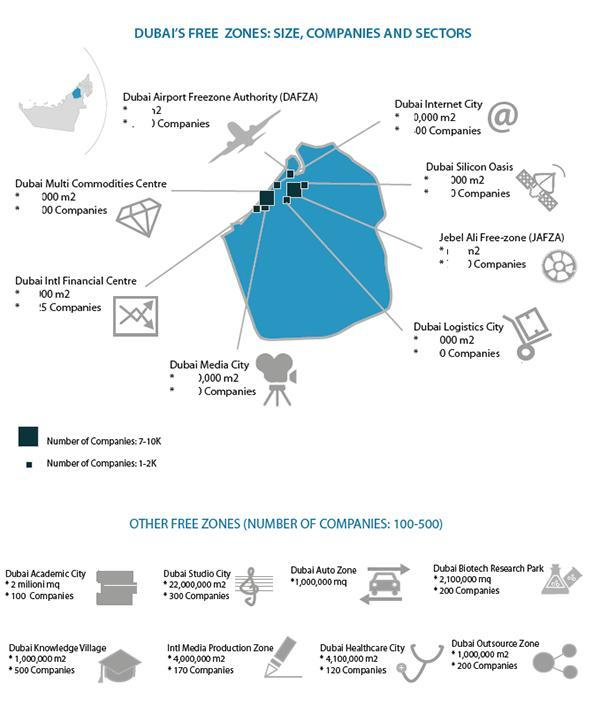Which company listed on the left hand side of the map has 7-10K companies in it?
Answer the question with a short phrase. Dubai Multi Commodities Centre 